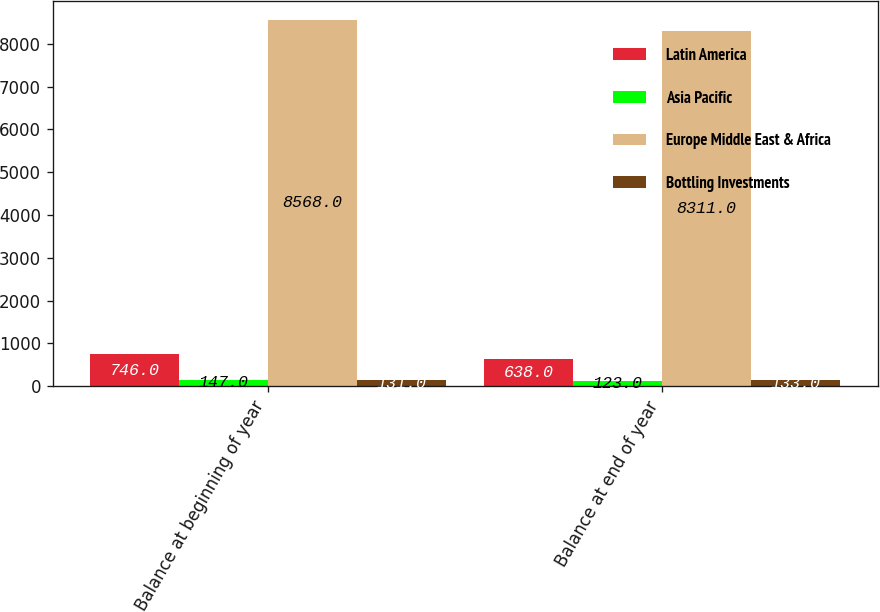Convert chart. <chart><loc_0><loc_0><loc_500><loc_500><stacked_bar_chart><ecel><fcel>Balance at beginning of year<fcel>Balance at end of year<nl><fcel>Latin America<fcel>746<fcel>638<nl><fcel>Asia Pacific<fcel>147<fcel>123<nl><fcel>Europe Middle East & Africa<fcel>8568<fcel>8311<nl><fcel>Bottling Investments<fcel>131<fcel>133<nl></chart> 